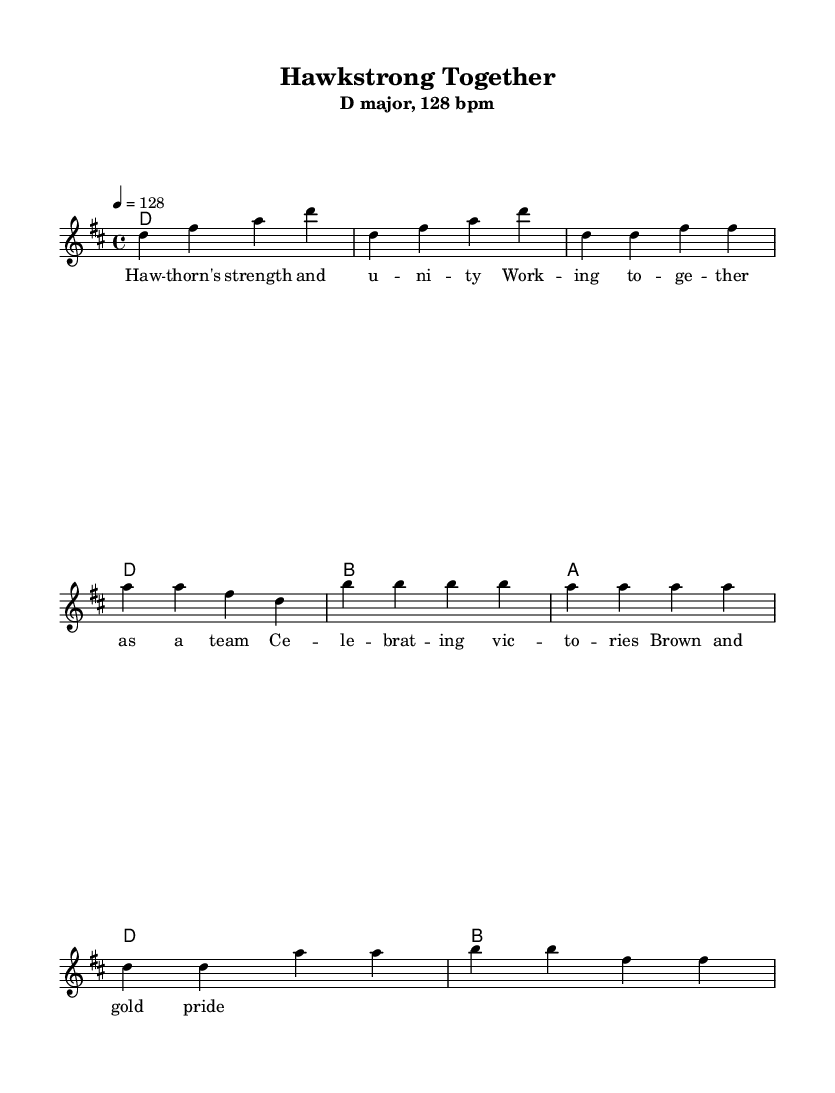What is the key signature of this music? The key signature is indicated at the beginning of the score, following the \key command. It shows that the piece is in D major, which has two sharps (F# and C#).
Answer: D major What is the time signature of this music? The time signature is shown next to the key signature at the beginning of the score, represented by 4/4. This means there are four beats per measure, and the quarter note gets one beat.
Answer: 4/4 What is the tempo marking of this music? The tempo marking is indicated by the \tempo command at the start of the score. It specifies that the piece should be played at a speed of 128 beats per minute.
Answer: 128 bpm How many measures are in the verse section? The verse is denoted in the sheet music and consists of eight beats, grouped into two measures of 4/4 time. Counting these beats gives a total of two measures.
Answer: 2 What is the first note of the chorus? The first note of the chorus can be found in the melody section after the pre-chorus. It starts with the note D in the fourth measure of the chorus.
Answer: D What theme is expressed in the lyrics of this piece? The lyrics focus on teamwork, strength, and unity, as evidenced by words like "strength," "working together," and "celebrating victories," reflecting a collective spirit of achievement among the team.
Answer: Teamwork and unity What musical form does this piece exemplify? This piece follows a common song structure, alternating between verses and choruses, which is typical in many dance anthems. This repetitive structure enhances its energetic and celebratory theme.
Answer: Verse-Chorus form 